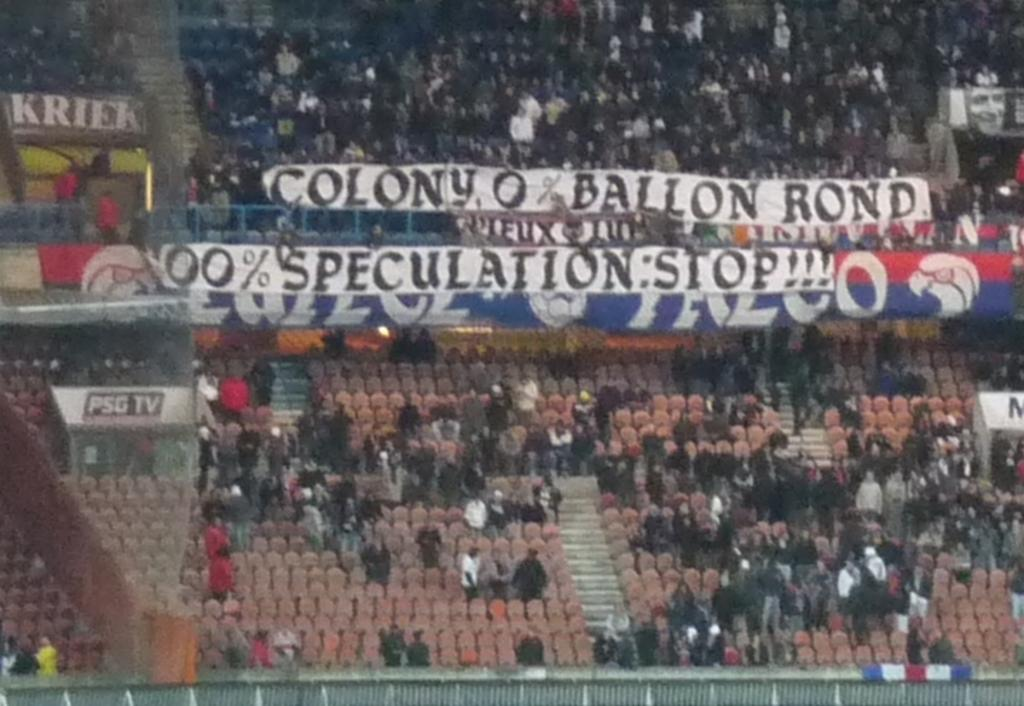Where was the image taken? The image was taken in a stadium. What can be seen in the front of the image? There is a large crowd in the front of the image. What decorative elements are visible in the image? Banners are visible in the image. What type of seating is present in the image? Chairs are present in the image. What type of barrier is at the bottom of the image? There is fencing at the bottom of the image. What is the name of the woman sitting in the front row of the image? There is no woman present in the image, so it is not possible to determine her name. 